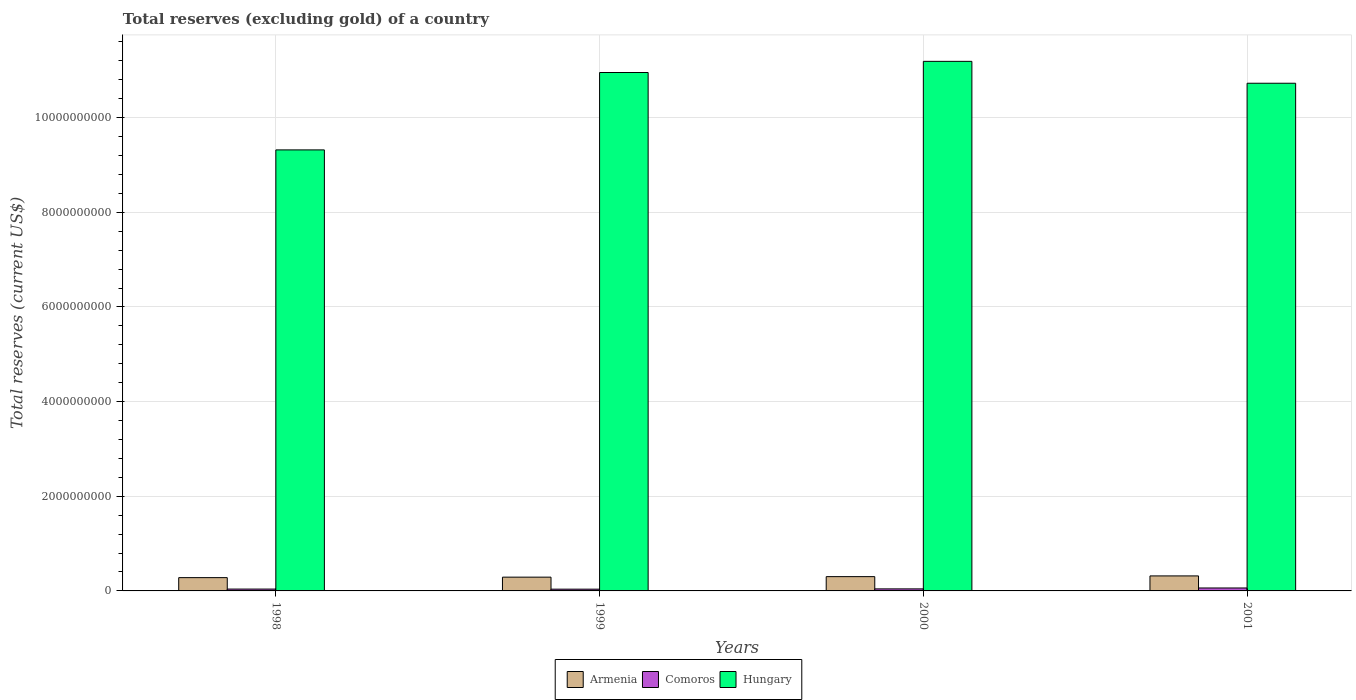Are the number of bars per tick equal to the number of legend labels?
Give a very brief answer. Yes. Are the number of bars on each tick of the X-axis equal?
Offer a terse response. Yes. What is the total reserves (excluding gold) in Comoros in 2001?
Provide a short and direct response. 6.23e+07. Across all years, what is the maximum total reserves (excluding gold) in Hungary?
Provide a short and direct response. 1.12e+1. Across all years, what is the minimum total reserves (excluding gold) in Comoros?
Provide a short and direct response. 3.71e+07. In which year was the total reserves (excluding gold) in Armenia maximum?
Your response must be concise. 2001. What is the total total reserves (excluding gold) in Hungary in the graph?
Offer a terse response. 4.22e+1. What is the difference between the total reserves (excluding gold) in Hungary in 1999 and that in 2001?
Your answer should be compact. 2.27e+08. What is the difference between the total reserves (excluding gold) in Hungary in 1998 and the total reserves (excluding gold) in Armenia in 2001?
Your response must be concise. 9.00e+09. What is the average total reserves (excluding gold) in Comoros per year?
Keep it short and to the point. 4.55e+07. In the year 2001, what is the difference between the total reserves (excluding gold) in Comoros and total reserves (excluding gold) in Hungary?
Your response must be concise. -1.07e+1. In how many years, is the total reserves (excluding gold) in Comoros greater than 7600000000 US$?
Keep it short and to the point. 0. What is the ratio of the total reserves (excluding gold) in Comoros in 1998 to that in 2001?
Your answer should be very brief. 0.63. Is the total reserves (excluding gold) in Comoros in 1998 less than that in 2001?
Your response must be concise. Yes. What is the difference between the highest and the second highest total reserves (excluding gold) in Hungary?
Keep it short and to the point. 2.36e+08. What is the difference between the highest and the lowest total reserves (excluding gold) in Comoros?
Your response must be concise. 2.52e+07. In how many years, is the total reserves (excluding gold) in Hungary greater than the average total reserves (excluding gold) in Hungary taken over all years?
Offer a very short reply. 3. What does the 1st bar from the left in 2000 represents?
Offer a terse response. Armenia. What does the 3rd bar from the right in 2001 represents?
Give a very brief answer. Armenia. Are all the bars in the graph horizontal?
Make the answer very short. No. Are the values on the major ticks of Y-axis written in scientific E-notation?
Give a very brief answer. No. How many legend labels are there?
Provide a short and direct response. 3. How are the legend labels stacked?
Offer a terse response. Horizontal. What is the title of the graph?
Make the answer very short. Total reserves (excluding gold) of a country. Does "Solomon Islands" appear as one of the legend labels in the graph?
Your response must be concise. No. What is the label or title of the X-axis?
Keep it short and to the point. Years. What is the label or title of the Y-axis?
Keep it short and to the point. Total reserves (current US$). What is the Total reserves (current US$) in Armenia in 1998?
Offer a very short reply. 2.81e+08. What is the Total reserves (current US$) of Comoros in 1998?
Give a very brief answer. 3.91e+07. What is the Total reserves (current US$) of Hungary in 1998?
Ensure brevity in your answer.  9.32e+09. What is the Total reserves (current US$) in Armenia in 1999?
Provide a short and direct response. 2.91e+08. What is the Total reserves (current US$) of Comoros in 1999?
Provide a short and direct response. 3.71e+07. What is the Total reserves (current US$) in Hungary in 1999?
Keep it short and to the point. 1.10e+1. What is the Total reserves (current US$) in Armenia in 2000?
Your response must be concise. 3.02e+08. What is the Total reserves (current US$) of Comoros in 2000?
Offer a very short reply. 4.32e+07. What is the Total reserves (current US$) of Hungary in 2000?
Your answer should be very brief. 1.12e+1. What is the Total reserves (current US$) in Armenia in 2001?
Provide a succinct answer. 3.17e+08. What is the Total reserves (current US$) in Comoros in 2001?
Give a very brief answer. 6.23e+07. What is the Total reserves (current US$) in Hungary in 2001?
Offer a very short reply. 1.07e+1. Across all years, what is the maximum Total reserves (current US$) of Armenia?
Your answer should be very brief. 3.17e+08. Across all years, what is the maximum Total reserves (current US$) in Comoros?
Your answer should be very brief. 6.23e+07. Across all years, what is the maximum Total reserves (current US$) in Hungary?
Offer a very short reply. 1.12e+1. Across all years, what is the minimum Total reserves (current US$) of Armenia?
Your answer should be compact. 2.81e+08. Across all years, what is the minimum Total reserves (current US$) in Comoros?
Give a very brief answer. 3.71e+07. Across all years, what is the minimum Total reserves (current US$) in Hungary?
Provide a short and direct response. 9.32e+09. What is the total Total reserves (current US$) in Armenia in the graph?
Your response must be concise. 1.19e+09. What is the total Total reserves (current US$) of Comoros in the graph?
Offer a terse response. 1.82e+08. What is the total Total reserves (current US$) in Hungary in the graph?
Make the answer very short. 4.22e+1. What is the difference between the Total reserves (current US$) of Armenia in 1998 and that in 1999?
Offer a terse response. -1.01e+07. What is the difference between the Total reserves (current US$) of Comoros in 1998 and that in 1999?
Provide a succinct answer. 2.00e+06. What is the difference between the Total reserves (current US$) in Hungary in 1998 and that in 1999?
Ensure brevity in your answer.  -1.64e+09. What is the difference between the Total reserves (current US$) in Armenia in 1998 and that in 2000?
Your answer should be compact. -2.12e+07. What is the difference between the Total reserves (current US$) in Comoros in 1998 and that in 2000?
Keep it short and to the point. -4.07e+06. What is the difference between the Total reserves (current US$) of Hungary in 1998 and that in 2000?
Offer a terse response. -1.87e+09. What is the difference between the Total reserves (current US$) in Armenia in 1998 and that in 2001?
Ensure brevity in your answer.  -3.65e+07. What is the difference between the Total reserves (current US$) of Comoros in 1998 and that in 2001?
Ensure brevity in your answer.  -2.32e+07. What is the difference between the Total reserves (current US$) of Hungary in 1998 and that in 2001?
Your answer should be compact. -1.41e+09. What is the difference between the Total reserves (current US$) of Armenia in 1999 and that in 2000?
Your response must be concise. -1.11e+07. What is the difference between the Total reserves (current US$) in Comoros in 1999 and that in 2000?
Your answer should be compact. -6.06e+06. What is the difference between the Total reserves (current US$) in Hungary in 1999 and that in 2000?
Offer a very short reply. -2.36e+08. What is the difference between the Total reserves (current US$) of Armenia in 1999 and that in 2001?
Your answer should be compact. -2.64e+07. What is the difference between the Total reserves (current US$) of Comoros in 1999 and that in 2001?
Provide a succinct answer. -2.52e+07. What is the difference between the Total reserves (current US$) of Hungary in 1999 and that in 2001?
Your answer should be compact. 2.27e+08. What is the difference between the Total reserves (current US$) of Armenia in 2000 and that in 2001?
Offer a very short reply. -1.53e+07. What is the difference between the Total reserves (current US$) in Comoros in 2000 and that in 2001?
Keep it short and to the point. -1.91e+07. What is the difference between the Total reserves (current US$) of Hungary in 2000 and that in 2001?
Your answer should be very brief. 4.62e+08. What is the difference between the Total reserves (current US$) of Armenia in 1998 and the Total reserves (current US$) of Comoros in 1999?
Make the answer very short. 2.44e+08. What is the difference between the Total reserves (current US$) in Armenia in 1998 and the Total reserves (current US$) in Hungary in 1999?
Give a very brief answer. -1.07e+1. What is the difference between the Total reserves (current US$) in Comoros in 1998 and the Total reserves (current US$) in Hungary in 1999?
Your response must be concise. -1.09e+1. What is the difference between the Total reserves (current US$) of Armenia in 1998 and the Total reserves (current US$) of Comoros in 2000?
Your answer should be compact. 2.38e+08. What is the difference between the Total reserves (current US$) of Armenia in 1998 and the Total reserves (current US$) of Hungary in 2000?
Provide a short and direct response. -1.09e+1. What is the difference between the Total reserves (current US$) of Comoros in 1998 and the Total reserves (current US$) of Hungary in 2000?
Ensure brevity in your answer.  -1.12e+1. What is the difference between the Total reserves (current US$) in Armenia in 1998 and the Total reserves (current US$) in Comoros in 2001?
Keep it short and to the point. 2.18e+08. What is the difference between the Total reserves (current US$) in Armenia in 1998 and the Total reserves (current US$) in Hungary in 2001?
Make the answer very short. -1.04e+1. What is the difference between the Total reserves (current US$) of Comoros in 1998 and the Total reserves (current US$) of Hungary in 2001?
Offer a terse response. -1.07e+1. What is the difference between the Total reserves (current US$) in Armenia in 1999 and the Total reserves (current US$) in Comoros in 2000?
Your answer should be compact. 2.48e+08. What is the difference between the Total reserves (current US$) in Armenia in 1999 and the Total reserves (current US$) in Hungary in 2000?
Keep it short and to the point. -1.09e+1. What is the difference between the Total reserves (current US$) in Comoros in 1999 and the Total reserves (current US$) in Hungary in 2000?
Make the answer very short. -1.12e+1. What is the difference between the Total reserves (current US$) of Armenia in 1999 and the Total reserves (current US$) of Comoros in 2001?
Offer a terse response. 2.29e+08. What is the difference between the Total reserves (current US$) in Armenia in 1999 and the Total reserves (current US$) in Hungary in 2001?
Offer a very short reply. -1.04e+1. What is the difference between the Total reserves (current US$) of Comoros in 1999 and the Total reserves (current US$) of Hungary in 2001?
Your answer should be compact. -1.07e+1. What is the difference between the Total reserves (current US$) in Armenia in 2000 and the Total reserves (current US$) in Comoros in 2001?
Your answer should be very brief. 2.40e+08. What is the difference between the Total reserves (current US$) of Armenia in 2000 and the Total reserves (current US$) of Hungary in 2001?
Ensure brevity in your answer.  -1.04e+1. What is the difference between the Total reserves (current US$) in Comoros in 2000 and the Total reserves (current US$) in Hungary in 2001?
Ensure brevity in your answer.  -1.07e+1. What is the average Total reserves (current US$) in Armenia per year?
Give a very brief answer. 2.98e+08. What is the average Total reserves (current US$) of Comoros per year?
Your answer should be compact. 4.55e+07. What is the average Total reserves (current US$) in Hungary per year?
Give a very brief answer. 1.05e+1. In the year 1998, what is the difference between the Total reserves (current US$) in Armenia and Total reserves (current US$) in Comoros?
Your answer should be very brief. 2.42e+08. In the year 1998, what is the difference between the Total reserves (current US$) of Armenia and Total reserves (current US$) of Hungary?
Provide a short and direct response. -9.04e+09. In the year 1998, what is the difference between the Total reserves (current US$) in Comoros and Total reserves (current US$) in Hungary?
Provide a succinct answer. -9.28e+09. In the year 1999, what is the difference between the Total reserves (current US$) of Armenia and Total reserves (current US$) of Comoros?
Provide a short and direct response. 2.54e+08. In the year 1999, what is the difference between the Total reserves (current US$) in Armenia and Total reserves (current US$) in Hungary?
Provide a succinct answer. -1.07e+1. In the year 1999, what is the difference between the Total reserves (current US$) of Comoros and Total reserves (current US$) of Hungary?
Make the answer very short. -1.09e+1. In the year 2000, what is the difference between the Total reserves (current US$) in Armenia and Total reserves (current US$) in Comoros?
Offer a very short reply. 2.59e+08. In the year 2000, what is the difference between the Total reserves (current US$) in Armenia and Total reserves (current US$) in Hungary?
Make the answer very short. -1.09e+1. In the year 2000, what is the difference between the Total reserves (current US$) of Comoros and Total reserves (current US$) of Hungary?
Your answer should be compact. -1.11e+1. In the year 2001, what is the difference between the Total reserves (current US$) in Armenia and Total reserves (current US$) in Comoros?
Offer a terse response. 2.55e+08. In the year 2001, what is the difference between the Total reserves (current US$) in Armenia and Total reserves (current US$) in Hungary?
Offer a terse response. -1.04e+1. In the year 2001, what is the difference between the Total reserves (current US$) in Comoros and Total reserves (current US$) in Hungary?
Your answer should be very brief. -1.07e+1. What is the ratio of the Total reserves (current US$) of Armenia in 1998 to that in 1999?
Your answer should be very brief. 0.97. What is the ratio of the Total reserves (current US$) in Comoros in 1998 to that in 1999?
Your response must be concise. 1.05. What is the ratio of the Total reserves (current US$) of Hungary in 1998 to that in 1999?
Your answer should be very brief. 0.85. What is the ratio of the Total reserves (current US$) of Armenia in 1998 to that in 2000?
Offer a terse response. 0.93. What is the ratio of the Total reserves (current US$) in Comoros in 1998 to that in 2000?
Ensure brevity in your answer.  0.91. What is the ratio of the Total reserves (current US$) of Hungary in 1998 to that in 2000?
Provide a succinct answer. 0.83. What is the ratio of the Total reserves (current US$) of Armenia in 1998 to that in 2001?
Your answer should be compact. 0.89. What is the ratio of the Total reserves (current US$) in Comoros in 1998 to that in 2001?
Your answer should be very brief. 0.63. What is the ratio of the Total reserves (current US$) in Hungary in 1998 to that in 2001?
Provide a short and direct response. 0.87. What is the ratio of the Total reserves (current US$) in Armenia in 1999 to that in 2000?
Provide a succinct answer. 0.96. What is the ratio of the Total reserves (current US$) in Comoros in 1999 to that in 2000?
Provide a succinct answer. 0.86. What is the ratio of the Total reserves (current US$) of Hungary in 1999 to that in 2000?
Your answer should be very brief. 0.98. What is the ratio of the Total reserves (current US$) of Armenia in 1999 to that in 2001?
Ensure brevity in your answer.  0.92. What is the ratio of the Total reserves (current US$) in Comoros in 1999 to that in 2001?
Your answer should be very brief. 0.6. What is the ratio of the Total reserves (current US$) in Hungary in 1999 to that in 2001?
Provide a succinct answer. 1.02. What is the ratio of the Total reserves (current US$) of Armenia in 2000 to that in 2001?
Provide a succinct answer. 0.95. What is the ratio of the Total reserves (current US$) in Comoros in 2000 to that in 2001?
Offer a terse response. 0.69. What is the ratio of the Total reserves (current US$) in Hungary in 2000 to that in 2001?
Offer a terse response. 1.04. What is the difference between the highest and the second highest Total reserves (current US$) in Armenia?
Make the answer very short. 1.53e+07. What is the difference between the highest and the second highest Total reserves (current US$) in Comoros?
Provide a succinct answer. 1.91e+07. What is the difference between the highest and the second highest Total reserves (current US$) of Hungary?
Ensure brevity in your answer.  2.36e+08. What is the difference between the highest and the lowest Total reserves (current US$) of Armenia?
Make the answer very short. 3.65e+07. What is the difference between the highest and the lowest Total reserves (current US$) in Comoros?
Offer a terse response. 2.52e+07. What is the difference between the highest and the lowest Total reserves (current US$) in Hungary?
Keep it short and to the point. 1.87e+09. 